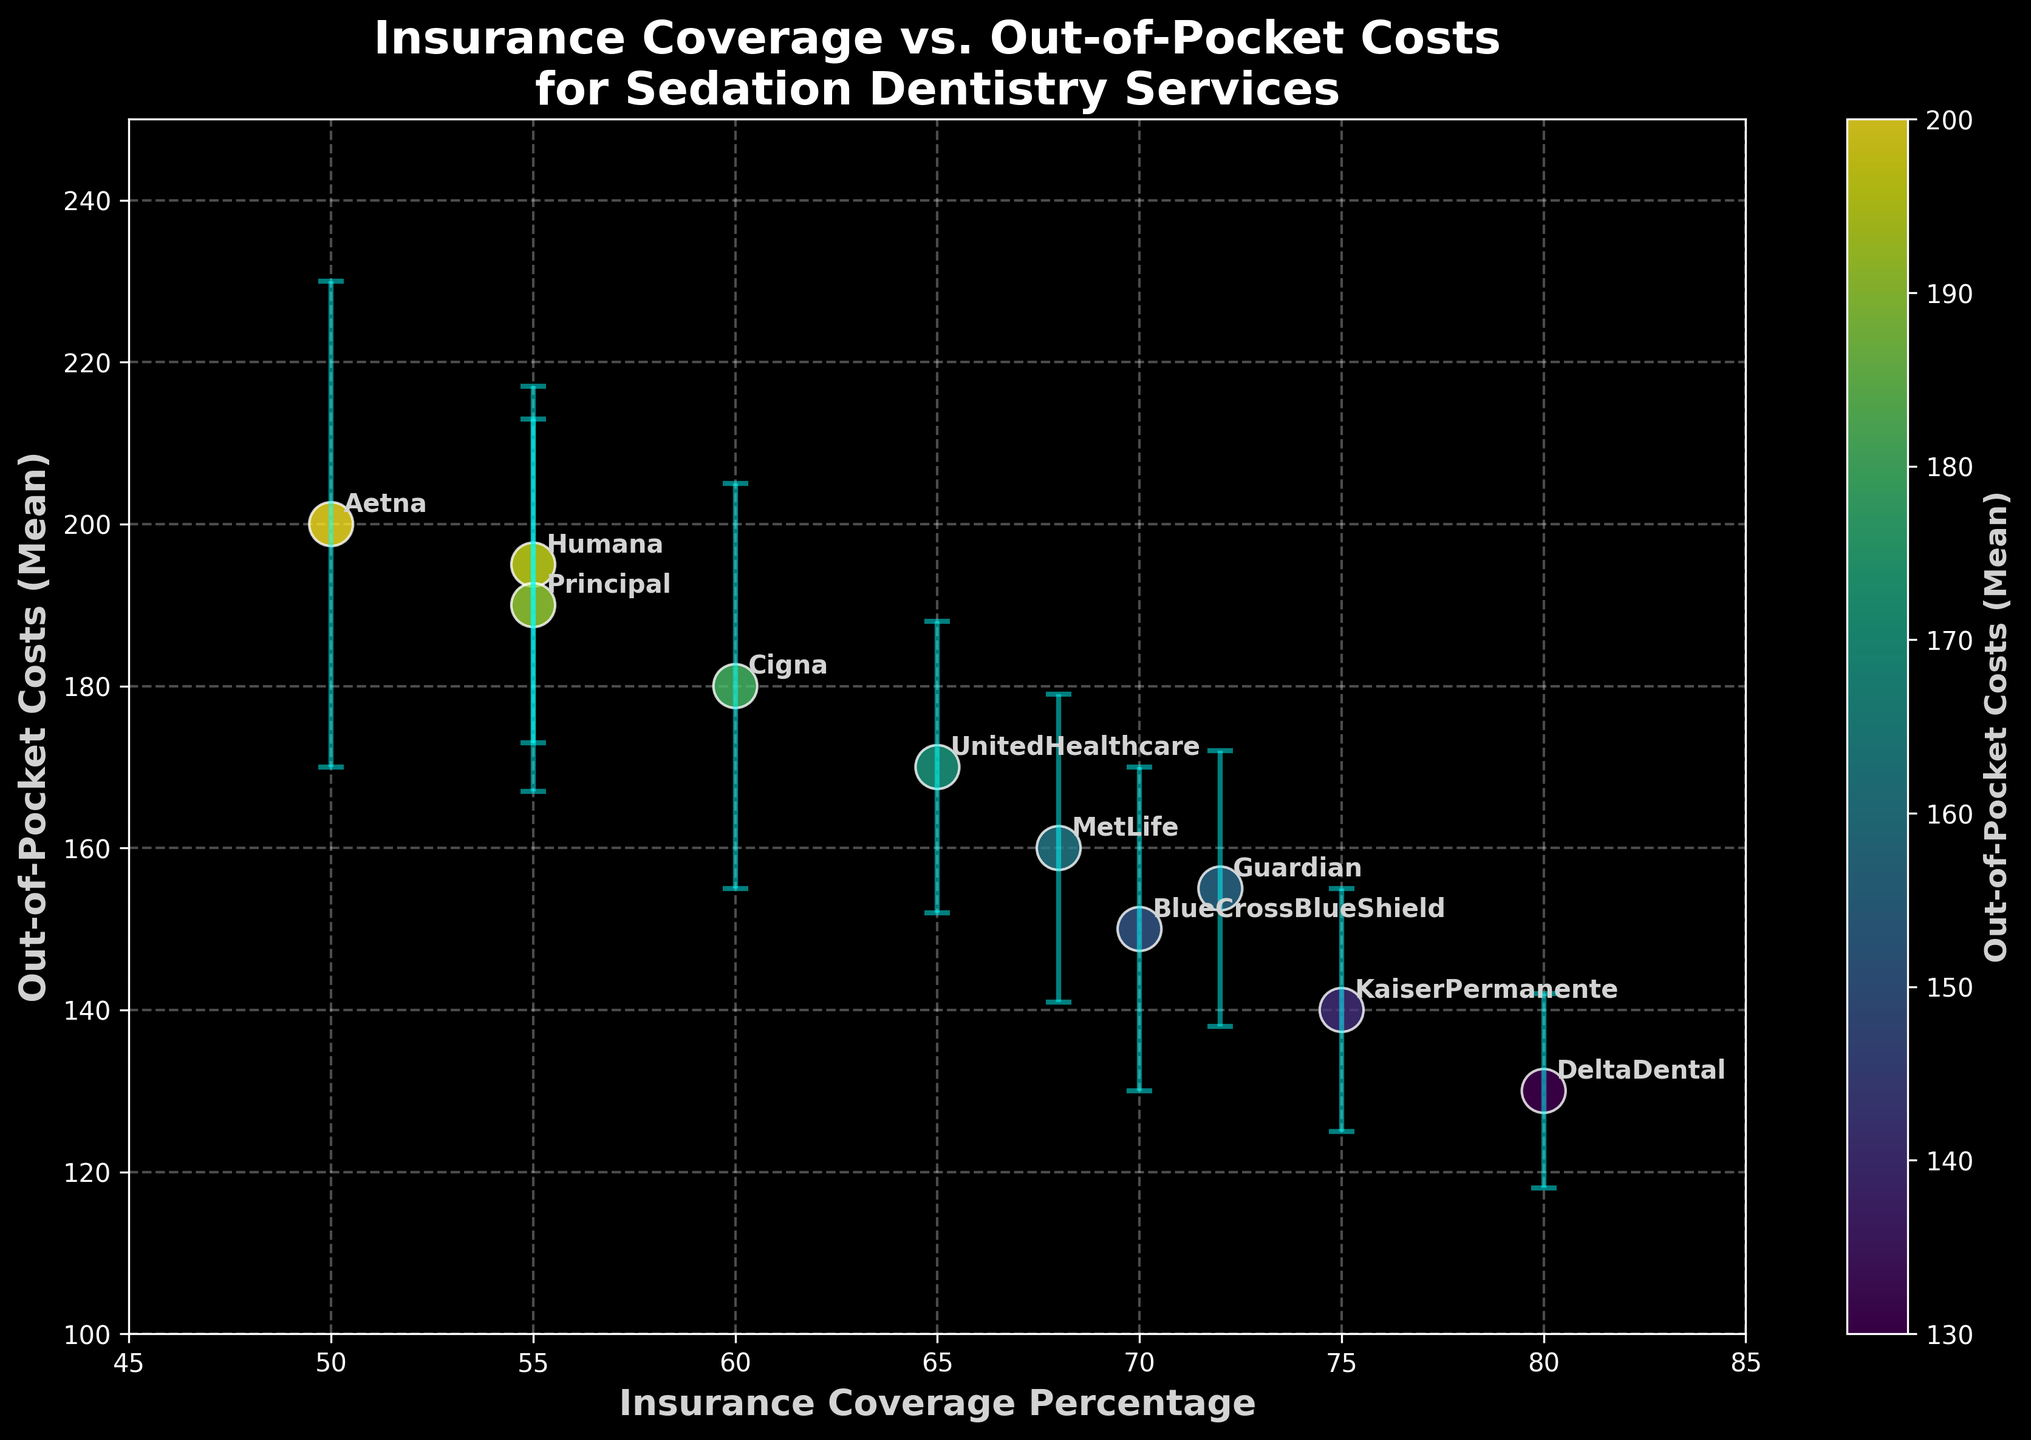What is the title of the plot? The title of the plot is located at the top and center of the figure. It provides a summary of what the figure represents. The title is "Insurance Coverage vs. Out-of-Pocket Costs for Sedation Dentistry Services".
Answer: Insurance Coverage vs. Out-of-Pocket Costs for Sedation Dentistry Services Which insurance provider has the highest out-of-pocket costs mean? Looking at the vertical position of the points, the provider with the highest y-value (out-of-pocket cost mean) can be identified. Aetna and its error bar reach the highest y-value of 200.
Answer: Aetna What is the range of insurance coverage percentages displayed on the x-axis? Observe the x-axis from the lowest to the highest value marked. The insurance coverage percentage values range from 45% to 85%.
Answer: 45% to 85% Which provider has the smallest out-of-pocket costs standard deviation? By examining the length of the error bars, Kaiser Permanente has the shortest error bar, indicating the smallest standard deviation of 12.
Answer: Kaiser Permanente What is the out-of-pocket costs mean for DeltaDental? Locate the DeltaDental label, then refer to the corresponding y-value for the mean out-of-pocket costs. DeltaDental has a mean out-of-pocket cost of 130.
Answer: 130 How does the out-of-pocket cost mean of Cigna compare to Humana? Locate both Cigna and Humana labels, then compare their y-values. Cigna's mean is 180, while Humana's mean is 195. Humana's mean is higher than Cigna's.
Answer: Humana's mean is higher Which providers have an insurance coverage percentage of 70% or more? Identify the points on or to the right of the 70% mark on the x-axis, and check the labels. BlueCrossBlueShield, KaiserPermanente, DeltaDental, Guardian all match this criterion.
Answer: BlueCrossBlueShield, KaiserPermanente, DeltaDental, Guardian What is the mean out-of-pocket costs and corresponding standard deviation for the provider with coverage percentage of 75%? Locate the point with 75% on the x-axis and check the corresponding y-value and error bar. Kaiser Permanente shows a mean out-of-pocket cost of 140 with a standard deviation of 15.
Answer: Mean: 140, SD: 15 How many insurance providers are shown in the plot? Each distinct label in the plot represents a different insurance provider. By counting the labels, we can determine there are ten providers.
Answer: 10 